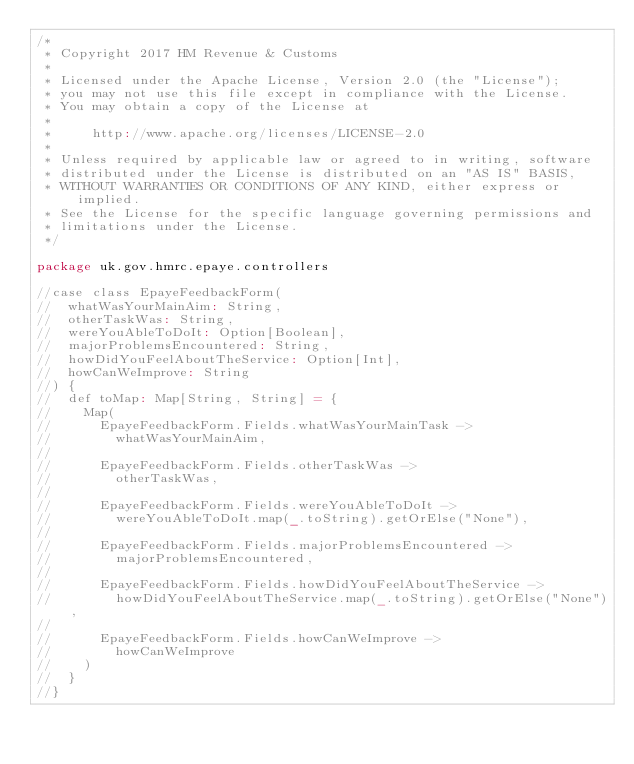<code> <loc_0><loc_0><loc_500><loc_500><_Scala_>/*
 * Copyright 2017 HM Revenue & Customs
 *
 * Licensed under the Apache License, Version 2.0 (the "License");
 * you may not use this file except in compliance with the License.
 * You may obtain a copy of the License at
 *
 *     http://www.apache.org/licenses/LICENSE-2.0
 *
 * Unless required by applicable law or agreed to in writing, software
 * distributed under the License is distributed on an "AS IS" BASIS,
 * WITHOUT WARRANTIES OR CONDITIONS OF ANY KIND, either express or implied.
 * See the License for the specific language governing permissions and
 * limitations under the License.
 */

package uk.gov.hmrc.epaye.controllers

//case class EpayeFeedbackForm(
//  whatWasYourMainAim: String,
//  otherTaskWas: String,
//  wereYouAbleToDoIt: Option[Boolean],
//  majorProblemsEncountered: String,
//  howDidYouFeelAboutTheService: Option[Int],
//  howCanWeImprove: String
//) {
//  def toMap: Map[String, String] = {
//    Map(
//      EpayeFeedbackForm.Fields.whatWasYourMainTask ->
//        whatWasYourMainAim,
//
//      EpayeFeedbackForm.Fields.otherTaskWas ->
//        otherTaskWas,
//
//      EpayeFeedbackForm.Fields.wereYouAbleToDoIt ->
//        wereYouAbleToDoIt.map(_.toString).getOrElse("None"),
//
//      EpayeFeedbackForm.Fields.majorProblemsEncountered ->
//        majorProblemsEncountered,
//
//      EpayeFeedbackForm.Fields.howDidYouFeelAboutTheService ->
//        howDidYouFeelAboutTheService.map(_.toString).getOrElse("None"),
//
//      EpayeFeedbackForm.Fields.howCanWeImprove ->
//        howCanWeImprove
//    )
//  }
//}
</code> 